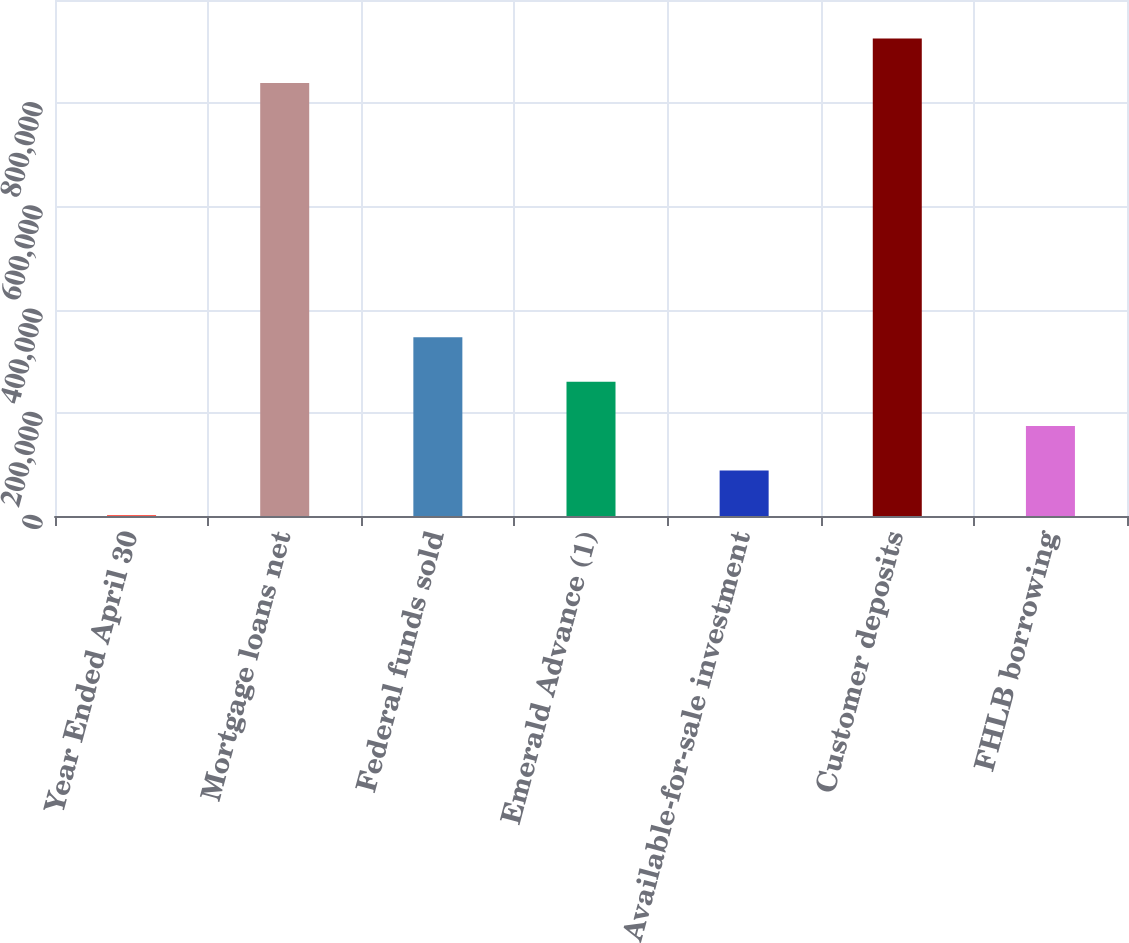Convert chart. <chart><loc_0><loc_0><loc_500><loc_500><bar_chart><fcel>Year Ended April 30<fcel>Mortgage loans net<fcel>Federal funds sold<fcel>Emerald Advance (1)<fcel>Available-for-sale investment<fcel>Customer deposits<fcel>FHLB borrowing<nl><fcel>2009<fcel>839253<fcel>346434<fcel>260328<fcel>88115.3<fcel>925359<fcel>174222<nl></chart> 